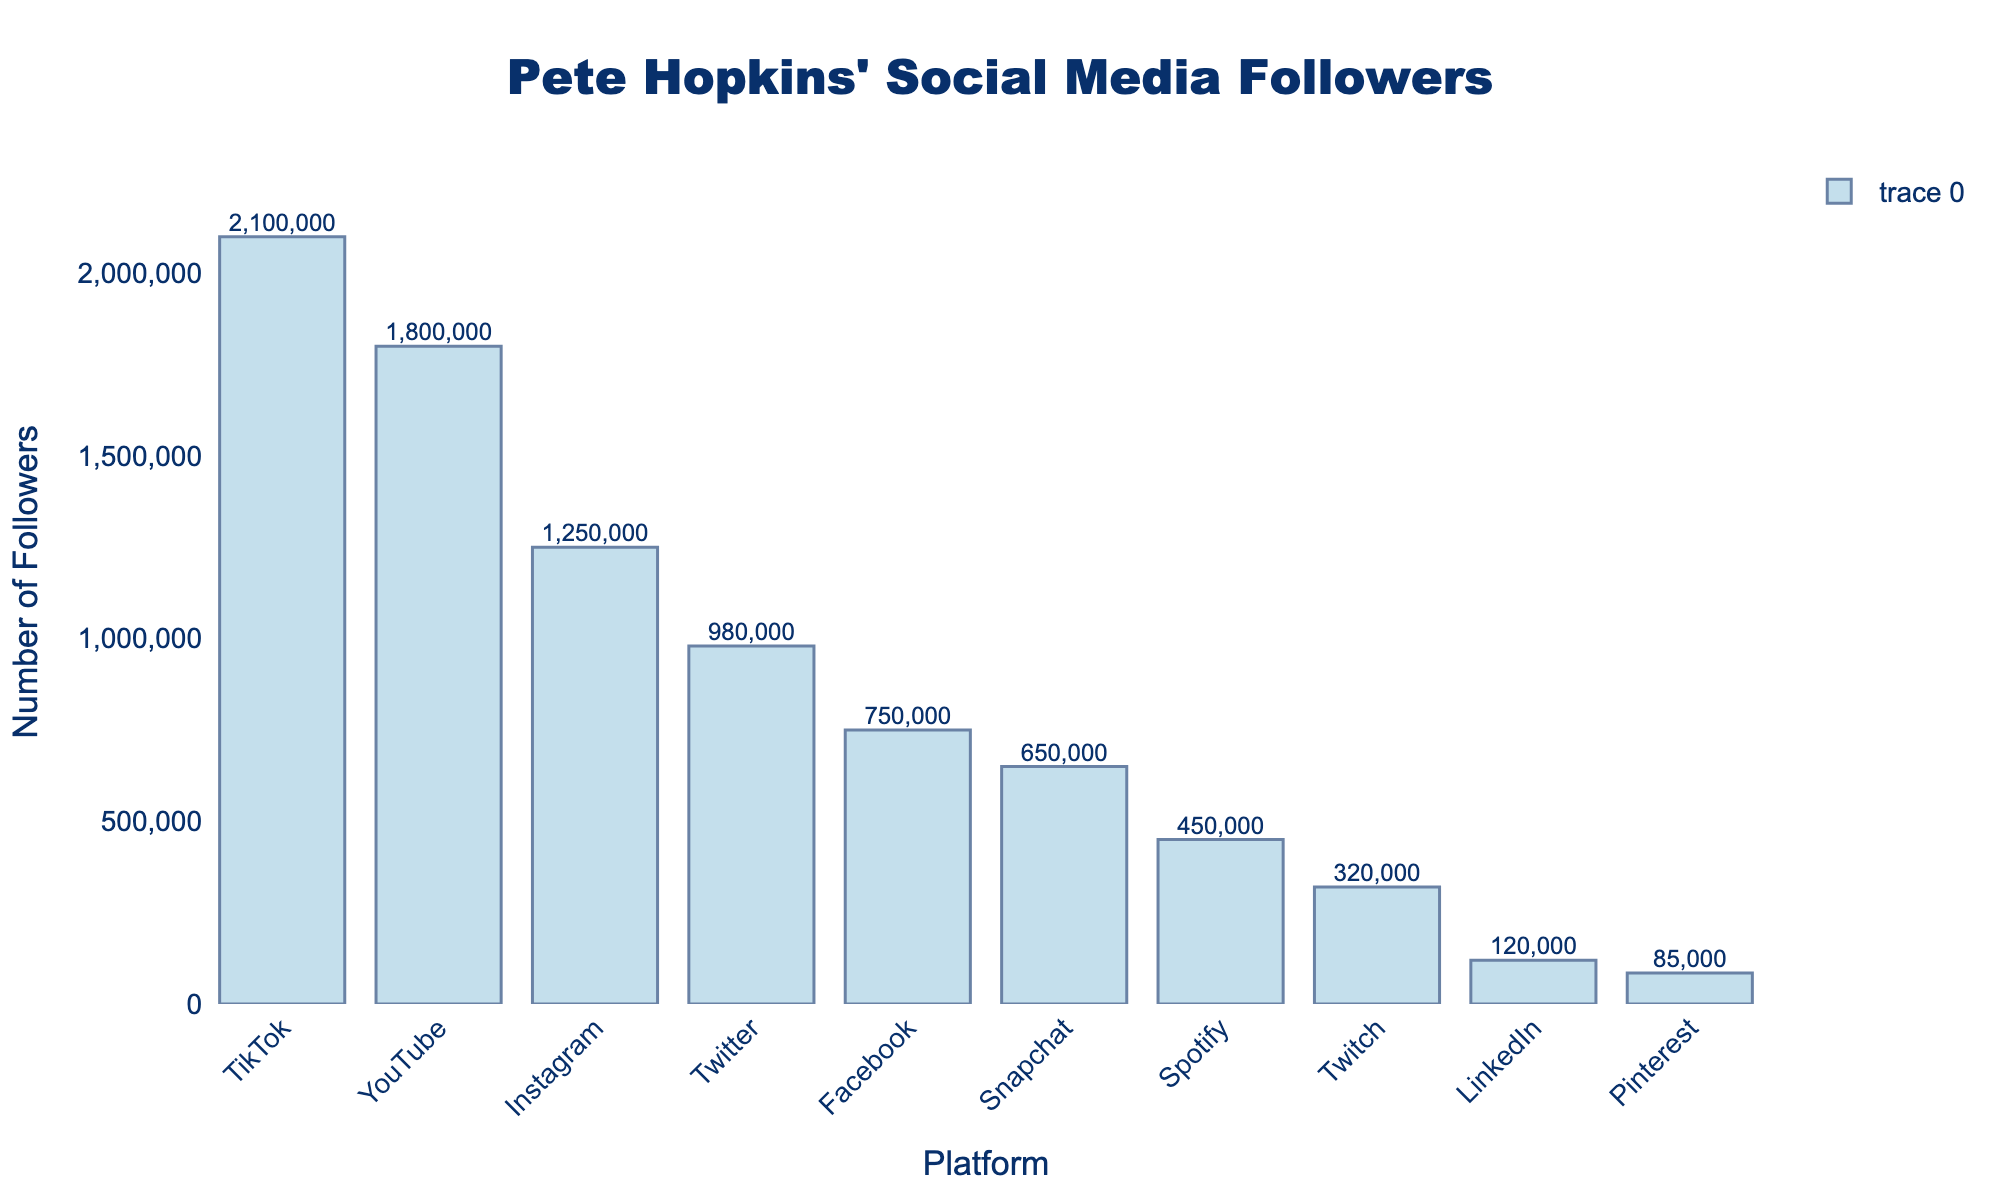Which social media platform does Pete Hopkins have the most followers on? By visually assessing the height of the bars, we can see that TikTok has the tallest bar, indicating it has the most followers.
Answer: TikTok Which platform has the fewest followers? The bar for Pinterest is the shortest, indicating that it has the fewest followers.
Answer: Pinterest How many more followers does Pete have on YouTube compared to Snapchat? Look at the height of the bars for YouTube and Snapchat. YouTube has 1,800,000 followers, and Snapchat has 650,000 followers. The difference is 1,800,000 - 650,000.
Answer: 1,150,000 On which platforms does Pete have more than 1,000,000 followers? Identify the platforms with bars exceeding the 1,000,000 mark. These platforms are Instagram (1,250,000), Twitter (980,000), YouTube (1,800,000), and TikTok (2,100,000).
Answer: Instagram, YouTube, TikTok How many platforms does Pete have fewer than a million followers on? Count the number of bars that fall below the 1,000,000 mark. These include Facebook (750,000), Snapchat (650,000), Pinterest (85,000), LinkedIn (120,000), Twitch (320,000), and Spotify (450,000).
Answer: 6 What is the total number of followers across all platforms? Sum the followers across all platforms: 1,250,000 (Instagram) + 980,000 (Twitter) + 2,100,000 (TikTok) + 750,000 (Facebook) + 1,800,000 (YouTube) + 120,000 (LinkedIn) + 650,000 (Snapchat) + 85,000 (Pinterest) + 320,000 (Twitch) + 450,000 (Spotify).
Answer: 8,505,000 How does the number of followers on Instagram compare to Twitter? Visually compare the heights of the bars for Instagram and Twitter. Instagram has 1,250,000 followers, while Twitter has 980,000. Instagram has more followers by 1,250,000 - 980,000.
Answer: 270,000 more Which platforms have around half a million to a million followers? Check the bars within this range (500,000 - 1,000,000). Platforms with followers in this range are Facebook (750,000), Snapchat (650,000), and Spotify (450,000, though slightly below half a million).
Answer: Facebook, Snapchat Which platforms have over 1.5 million followers? Identify bars that exceed the 1,500,000 mark, which are YouTube (1,800,000) and TikTok (2,100,000).
Answer: YouTube, TikTok How many platforms have fewer followers than LinkedIn? Compare LinkedIn's followers (120,000) to other platforms. Only Pinterest (85,000) has fewer followers.
Answer: 1 